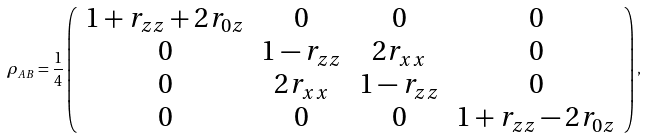Convert formula to latex. <formula><loc_0><loc_0><loc_500><loc_500>\rho _ { A B } = \frac { 1 } { 4 } \left ( \begin{array} { c c c c } 1 + r _ { z z } + 2 r _ { 0 z } & 0 & 0 & 0 \\ 0 & 1 - r _ { z z } & 2 r _ { x x } & 0 \\ 0 & 2 r _ { x x } & 1 - r _ { z z } & 0 \\ 0 & 0 & 0 & 1 + r _ { z z } - 2 r _ { 0 z } \end{array} \right ) ,</formula> 